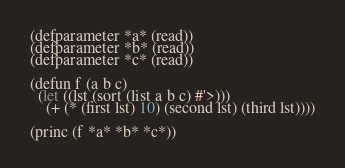Convert code to text. <code><loc_0><loc_0><loc_500><loc_500><_Lisp_>(defparameter *a* (read))
(defparameter *b* (read))
(defparameter *c* (read))

(defun f (a b c)
  (let ((lst (sort (list a b c) #'>)))
    (+ (* (first lst) 10) (second lst) (third lst))))

(princ (f *a* *b* *c*))</code> 